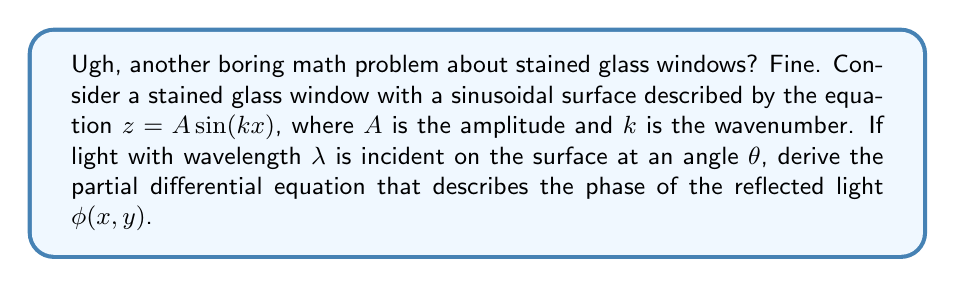Can you answer this question? Alright, let's get this over with:

1) The phase of the reflected light is given by the optical path difference (OPD) multiplied by $2\pi/\lambda$:

   $\phi(x,y) = \frac{2\pi}{\lambda} \text{OPD}(x,y)$

2) The OPD is twice the distance from the surface to a reference plane. This distance is $z \cos\theta$:

   $\text{OPD}(x,y) = 2z \cos\theta = 2A \sin(kx) \cos\theta$

3) Therefore, the phase is:

   $\phi(x,y) = \frac{4\pi A}{\lambda} \sin(kx) \cos\theta$

4) To get the PDE, we need to take partial derivatives:

   $\frac{\partial \phi}{\partial x} = \frac{4\pi A k}{\lambda} \cos(kx) \cos\theta$

   $\frac{\partial \phi}{\partial y} = 0$

5) Taking the second partial derivative with respect to $x$:

   $\frac{\partial^2 \phi}{\partial x^2} = -\frac{4\pi A k^2}{\lambda} \sin(kx) \cos\theta = -k^2 \phi(x,y)$

6) This gives us the final PDE:

   $\frac{\partial^2 \phi}{\partial x^2} + k^2 \phi(x,y) = 0$
Answer: $$\frac{\partial^2 \phi}{\partial x^2} + k^2 \phi(x,y) = 0$$ 